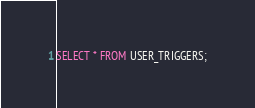Convert code to text. <code><loc_0><loc_0><loc_500><loc_500><_SQL_>SELECT * FROM USER_TRIGGERS;</code> 